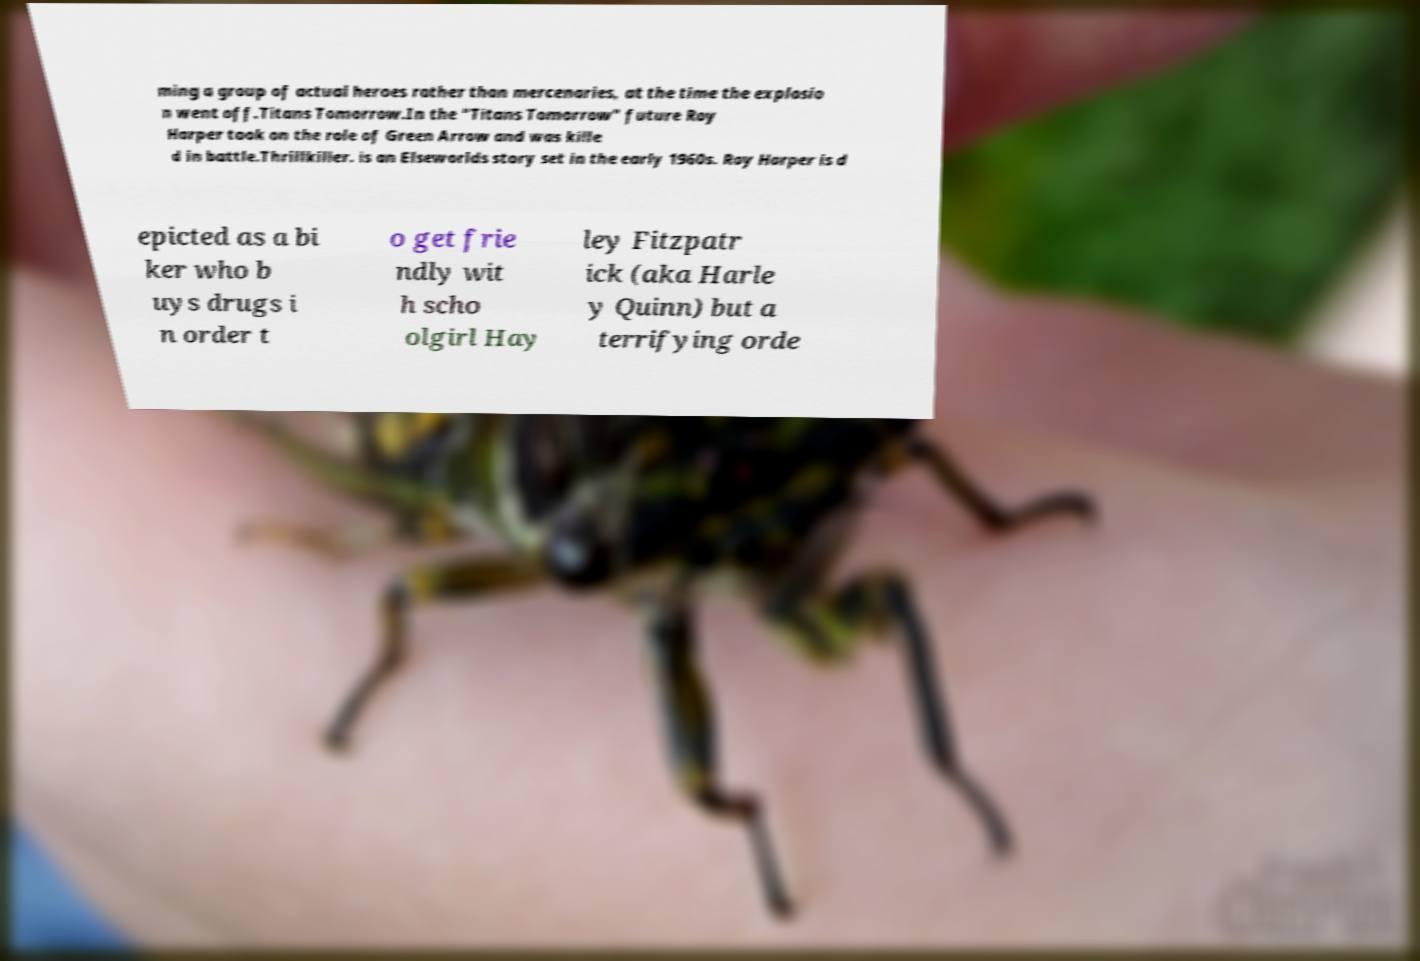I need the written content from this picture converted into text. Can you do that? ming a group of actual heroes rather than mercenaries, at the time the explosio n went off.Titans Tomorrow.In the "Titans Tomorrow" future Roy Harper took on the role of Green Arrow and was kille d in battle.Thrillkiller. is an Elseworlds story set in the early 1960s. Roy Harper is d epicted as a bi ker who b uys drugs i n order t o get frie ndly wit h scho olgirl Hay ley Fitzpatr ick (aka Harle y Quinn) but a terrifying orde 